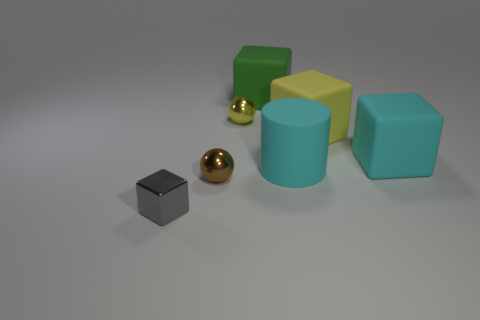What is the material of the block that is both left of the yellow cube and behind the large cyan cube? Given the composition and arrangement of objects in the image, the identified block left of the yellow cube and behind the large cyan cube appears to have a matte finish and consistent color, attributes often associated with a rubber material in such visual representations. 